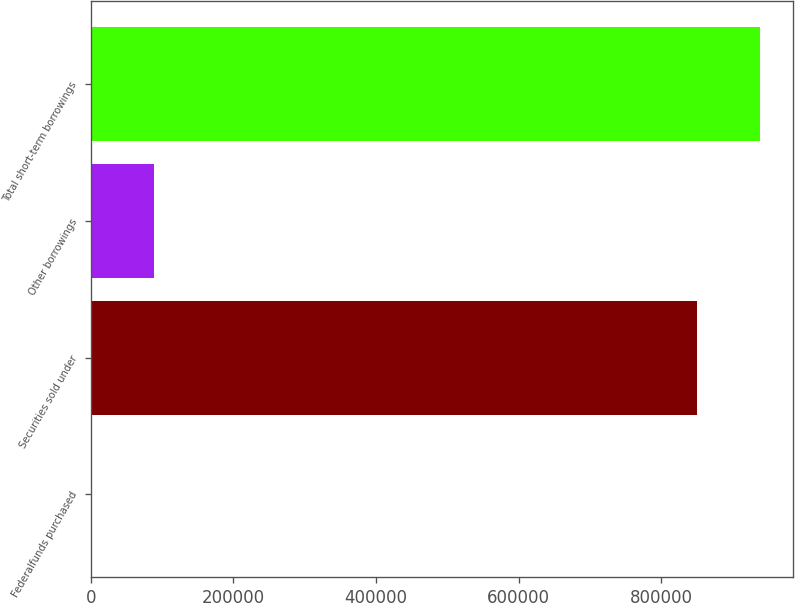Convert chart. <chart><loc_0><loc_0><loc_500><loc_500><bar_chart><fcel>Federalfunds purchased<fcel>Securities sold under<fcel>Other borrowings<fcel>Total short-term borrowings<nl><fcel>800<fcel>850485<fcel>88344.1<fcel>938029<nl></chart> 